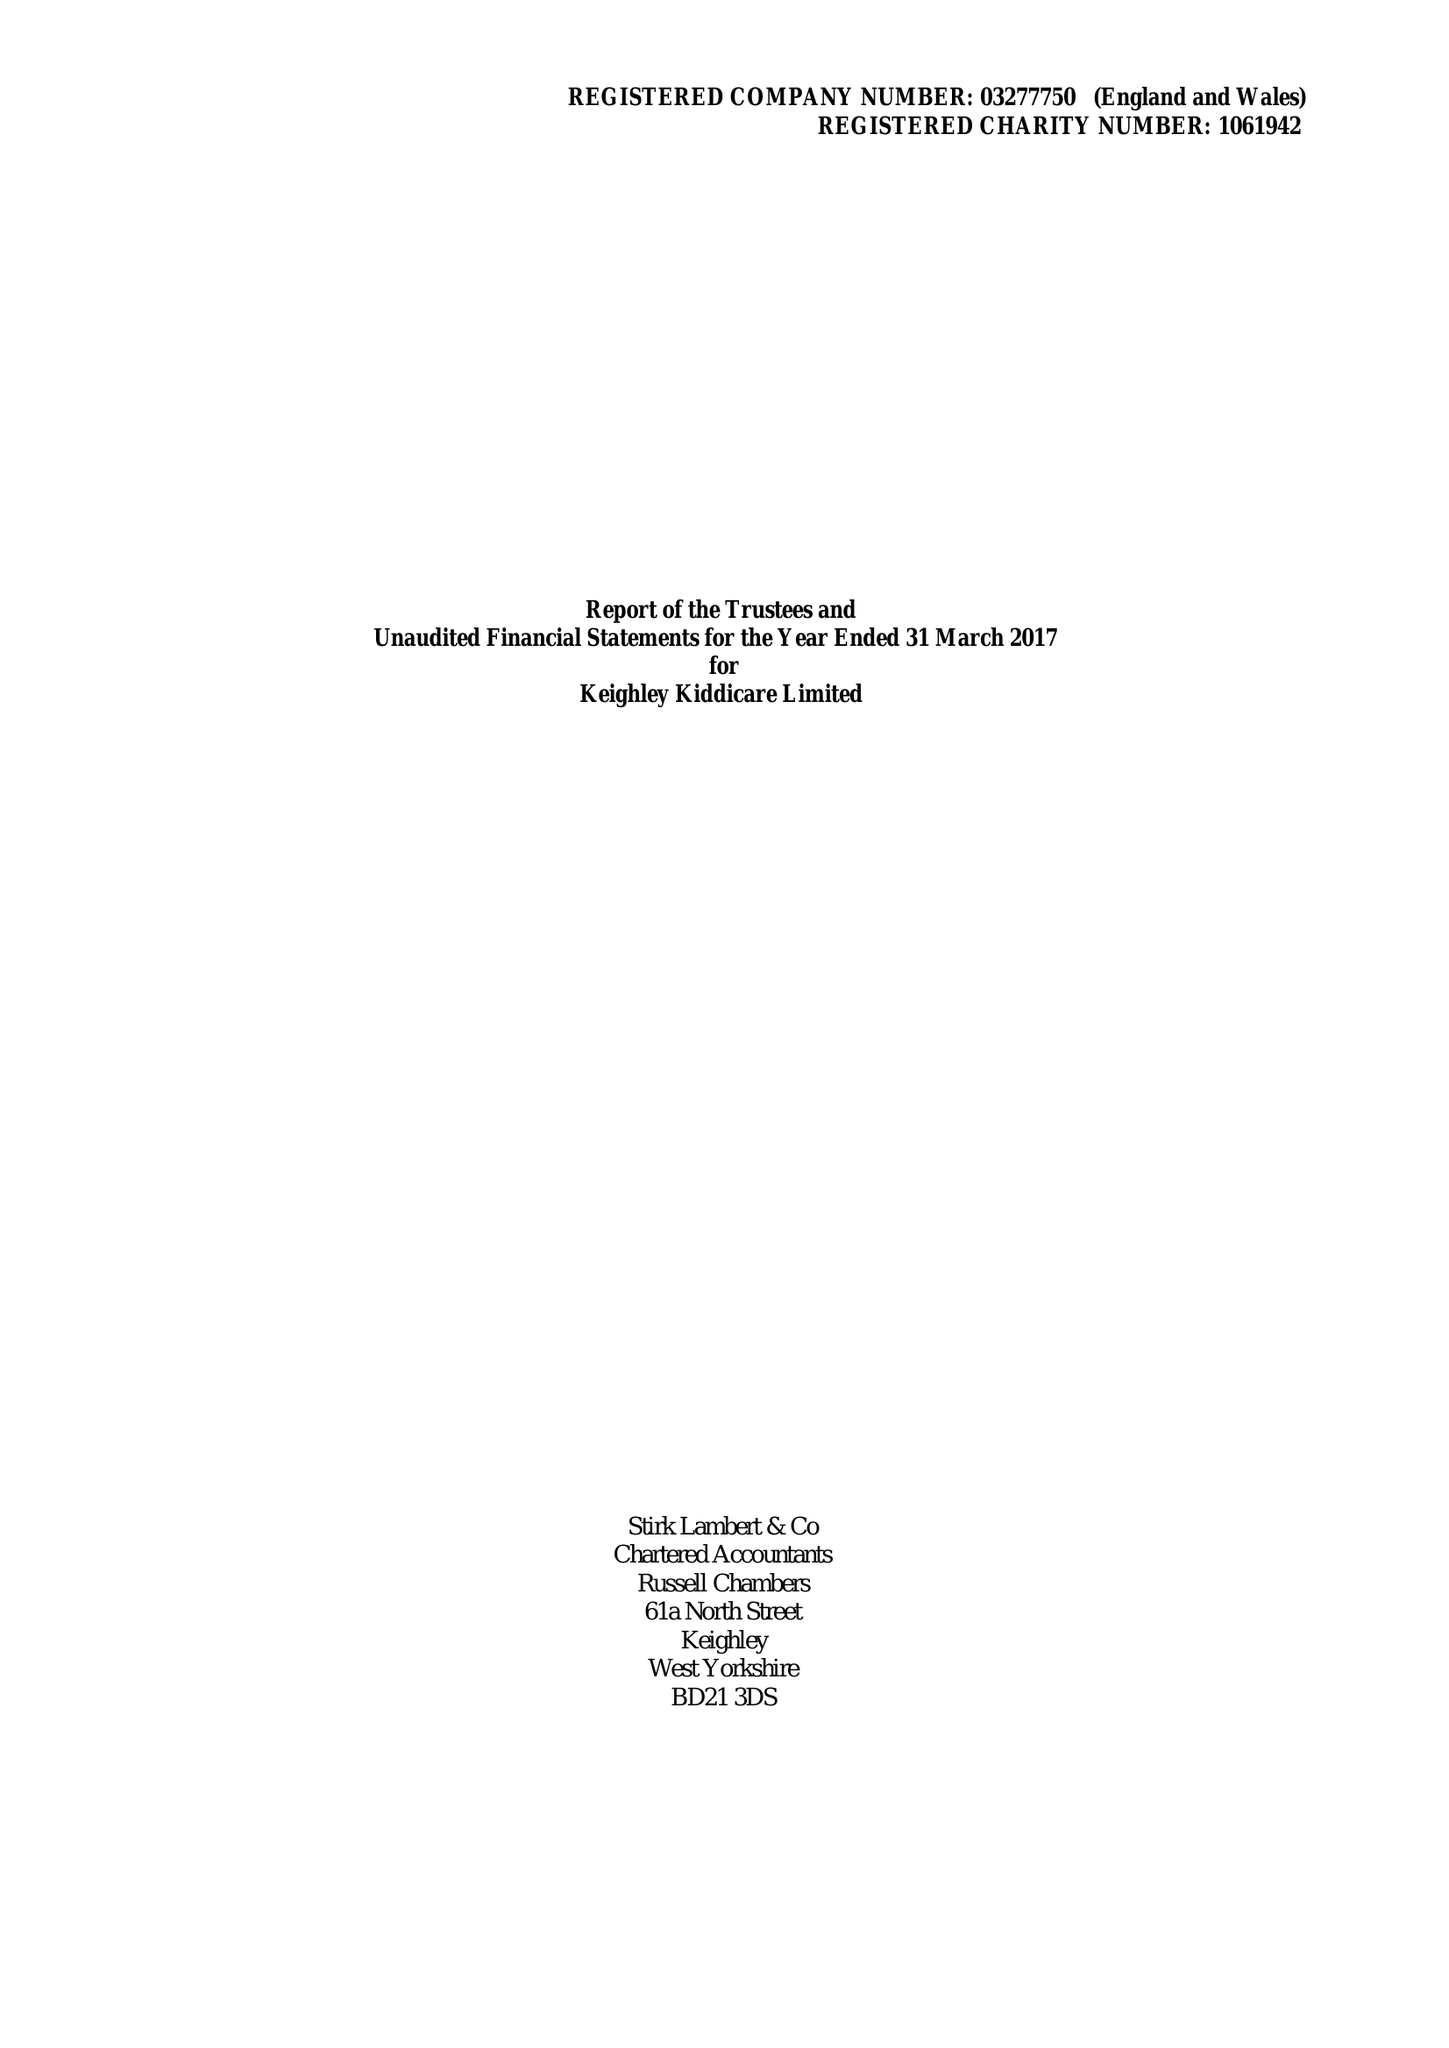What is the value for the spending_annually_in_british_pounds?
Answer the question using a single word or phrase. 442377.00 